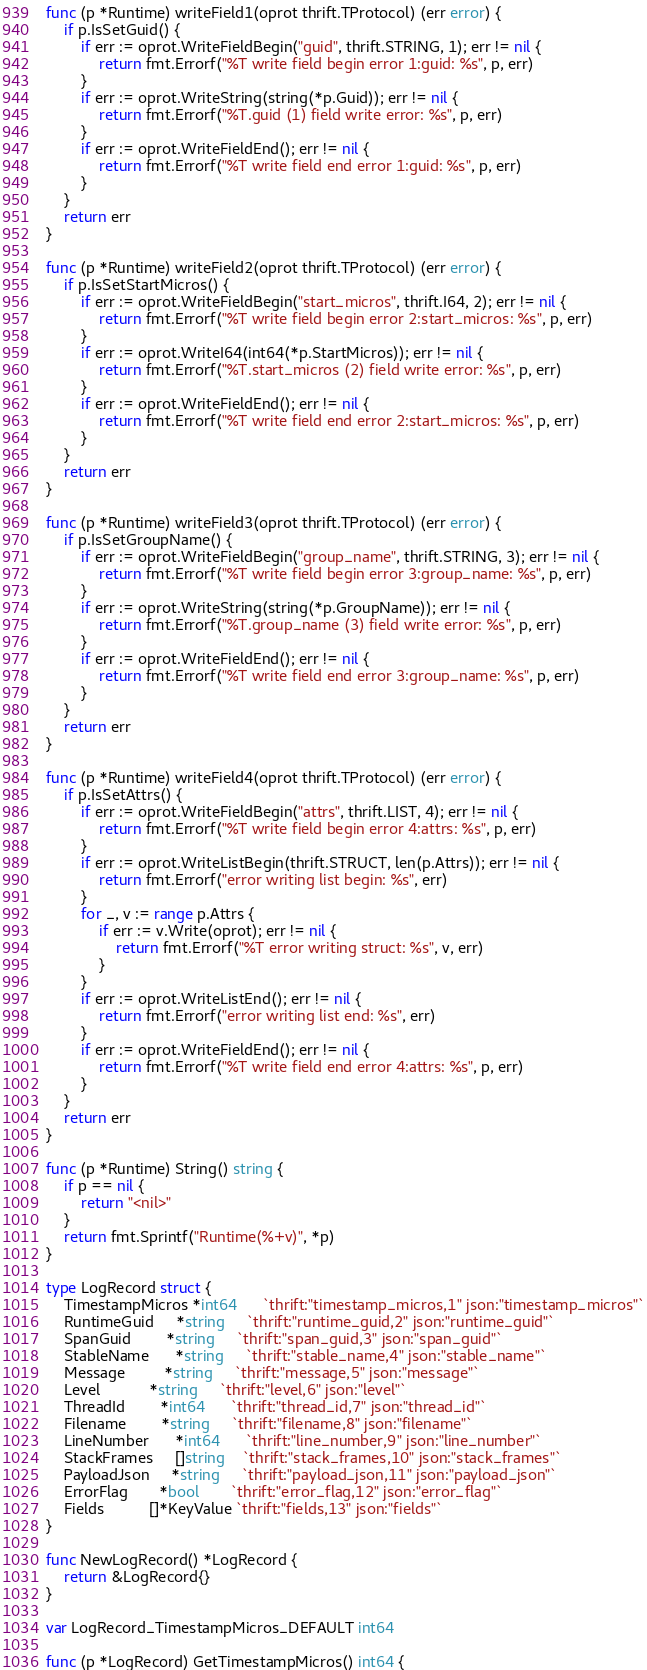Convert code to text. <code><loc_0><loc_0><loc_500><loc_500><_Go_>func (p *Runtime) writeField1(oprot thrift.TProtocol) (err error) {
	if p.IsSetGuid() {
		if err := oprot.WriteFieldBegin("guid", thrift.STRING, 1); err != nil {
			return fmt.Errorf("%T write field begin error 1:guid: %s", p, err)
		}
		if err := oprot.WriteString(string(*p.Guid)); err != nil {
			return fmt.Errorf("%T.guid (1) field write error: %s", p, err)
		}
		if err := oprot.WriteFieldEnd(); err != nil {
			return fmt.Errorf("%T write field end error 1:guid: %s", p, err)
		}
	}
	return err
}

func (p *Runtime) writeField2(oprot thrift.TProtocol) (err error) {
	if p.IsSetStartMicros() {
		if err := oprot.WriteFieldBegin("start_micros", thrift.I64, 2); err != nil {
			return fmt.Errorf("%T write field begin error 2:start_micros: %s", p, err)
		}
		if err := oprot.WriteI64(int64(*p.StartMicros)); err != nil {
			return fmt.Errorf("%T.start_micros (2) field write error: %s", p, err)
		}
		if err := oprot.WriteFieldEnd(); err != nil {
			return fmt.Errorf("%T write field end error 2:start_micros: %s", p, err)
		}
	}
	return err
}

func (p *Runtime) writeField3(oprot thrift.TProtocol) (err error) {
	if p.IsSetGroupName() {
		if err := oprot.WriteFieldBegin("group_name", thrift.STRING, 3); err != nil {
			return fmt.Errorf("%T write field begin error 3:group_name: %s", p, err)
		}
		if err := oprot.WriteString(string(*p.GroupName)); err != nil {
			return fmt.Errorf("%T.group_name (3) field write error: %s", p, err)
		}
		if err := oprot.WriteFieldEnd(); err != nil {
			return fmt.Errorf("%T write field end error 3:group_name: %s", p, err)
		}
	}
	return err
}

func (p *Runtime) writeField4(oprot thrift.TProtocol) (err error) {
	if p.IsSetAttrs() {
		if err := oprot.WriteFieldBegin("attrs", thrift.LIST, 4); err != nil {
			return fmt.Errorf("%T write field begin error 4:attrs: %s", p, err)
		}
		if err := oprot.WriteListBegin(thrift.STRUCT, len(p.Attrs)); err != nil {
			return fmt.Errorf("error writing list begin: %s", err)
		}
		for _, v := range p.Attrs {
			if err := v.Write(oprot); err != nil {
				return fmt.Errorf("%T error writing struct: %s", v, err)
			}
		}
		if err := oprot.WriteListEnd(); err != nil {
			return fmt.Errorf("error writing list end: %s", err)
		}
		if err := oprot.WriteFieldEnd(); err != nil {
			return fmt.Errorf("%T write field end error 4:attrs: %s", p, err)
		}
	}
	return err
}

func (p *Runtime) String() string {
	if p == nil {
		return "<nil>"
	}
	return fmt.Sprintf("Runtime(%+v)", *p)
}

type LogRecord struct {
	TimestampMicros *int64      `thrift:"timestamp_micros,1" json:"timestamp_micros"`
	RuntimeGuid     *string     `thrift:"runtime_guid,2" json:"runtime_guid"`
	SpanGuid        *string     `thrift:"span_guid,3" json:"span_guid"`
	StableName      *string     `thrift:"stable_name,4" json:"stable_name"`
	Message         *string     `thrift:"message,5" json:"message"`
	Level           *string     `thrift:"level,6" json:"level"`
	ThreadId        *int64      `thrift:"thread_id,7" json:"thread_id"`
	Filename        *string     `thrift:"filename,8" json:"filename"`
	LineNumber      *int64      `thrift:"line_number,9" json:"line_number"`
	StackFrames     []string    `thrift:"stack_frames,10" json:"stack_frames"`
	PayloadJson     *string     `thrift:"payload_json,11" json:"payload_json"`
	ErrorFlag       *bool       `thrift:"error_flag,12" json:"error_flag"`
	Fields          []*KeyValue `thrift:"fields,13" json:"fields"`
}

func NewLogRecord() *LogRecord {
	return &LogRecord{}
}

var LogRecord_TimestampMicros_DEFAULT int64

func (p *LogRecord) GetTimestampMicros() int64 {</code> 